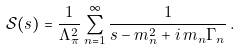Convert formula to latex. <formula><loc_0><loc_0><loc_500><loc_500>\mathcal { S } ( s ) = \frac { 1 } { \Lambda _ { \pi } ^ { 2 } } \sum _ { n = 1 } ^ { \infty } \frac { 1 } { s - m _ { n } ^ { 2 } + i \, m _ { n } \Gamma _ { n } } \, .</formula> 